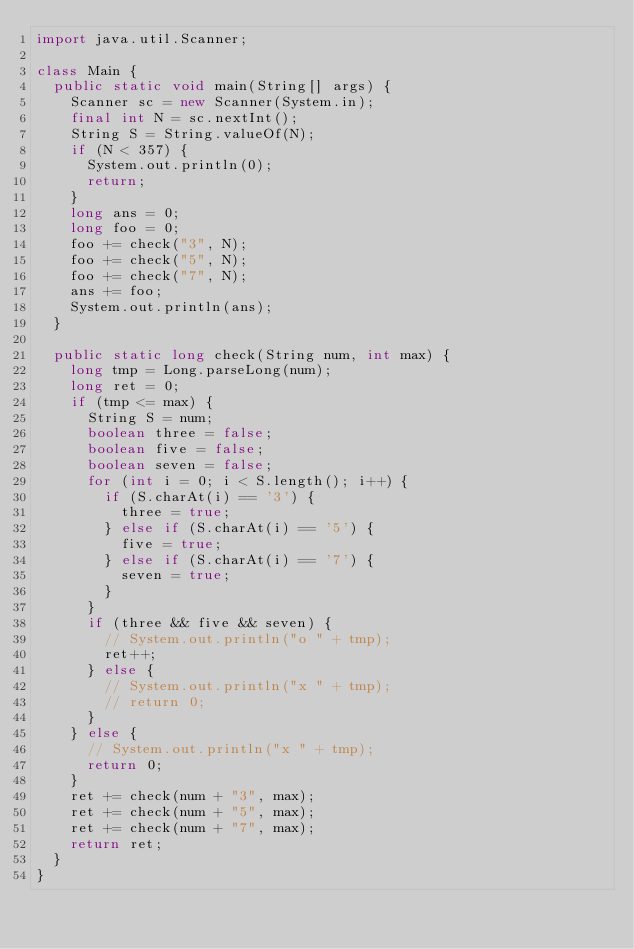<code> <loc_0><loc_0><loc_500><loc_500><_Java_>import java.util.Scanner;

class Main {
	public static void main(String[] args) {
		Scanner sc = new Scanner(System.in);
		final int N = sc.nextInt();
		String S = String.valueOf(N);
		if (N < 357) {
			System.out.println(0);
			return;
		}
		long ans = 0;
		long foo = 0;
		foo += check("3", N);
		foo += check("5", N);
		foo += check("7", N);
		ans += foo;
		System.out.println(ans);
	}

	public static long check(String num, int max) {
		long tmp = Long.parseLong(num);
		long ret = 0;
		if (tmp <= max) {
			String S = num;
			boolean three = false;
			boolean five = false;
			boolean seven = false;
			for (int i = 0; i < S.length(); i++) {
				if (S.charAt(i) == '3') {
					three = true;
				} else if (S.charAt(i) == '5') {
					five = true;
				} else if (S.charAt(i) == '7') {
					seven = true;
				}
			}
			if (three && five && seven) {
				// System.out.println("o " + tmp);
				ret++;
			} else {
				// System.out.println("x " + tmp);
				// return 0;
			}
		} else {
			// System.out.println("x " + tmp);
			return 0;
		}
		ret += check(num + "3", max);
		ret += check(num + "5", max);
		ret += check(num + "7", max);
		return ret;
	}
}</code> 